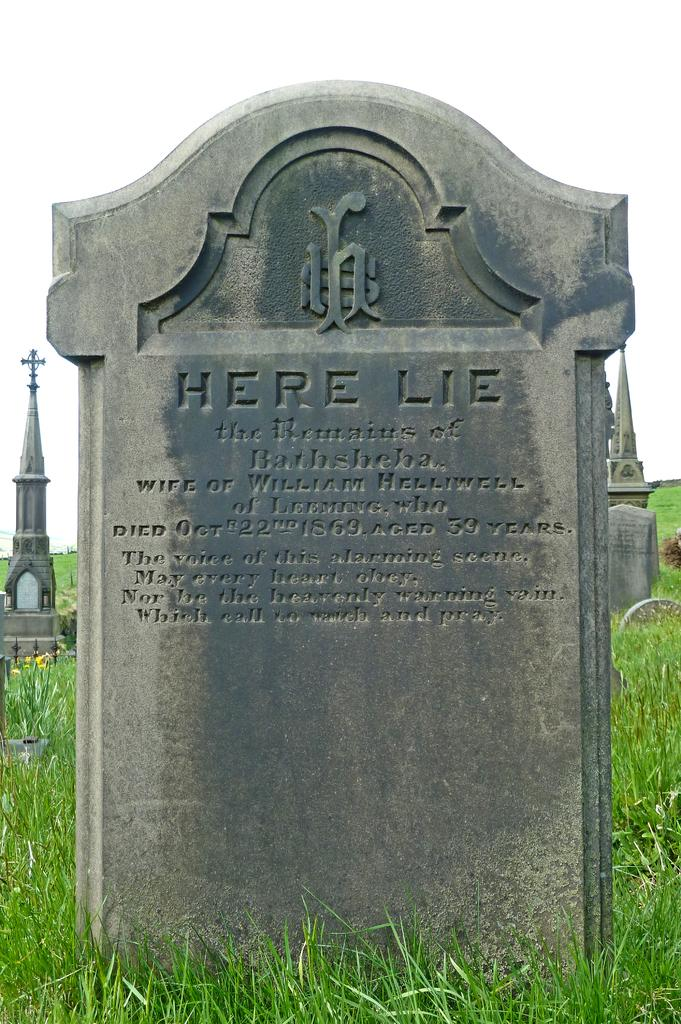What is the main subject of the image? There is a stone with writing on it in the image. What else can be seen in the image besides the stone with writing? There are stone objects and grass in the background of the image. What is visible in the sky in the image? The sky is visible in the background of the image. How many cherries are on the stone in the image? There are no cherries present in the image. Can you see a giraffe sleeping in the grass in the image? There is no giraffe or any indication of sleeping in the image. 